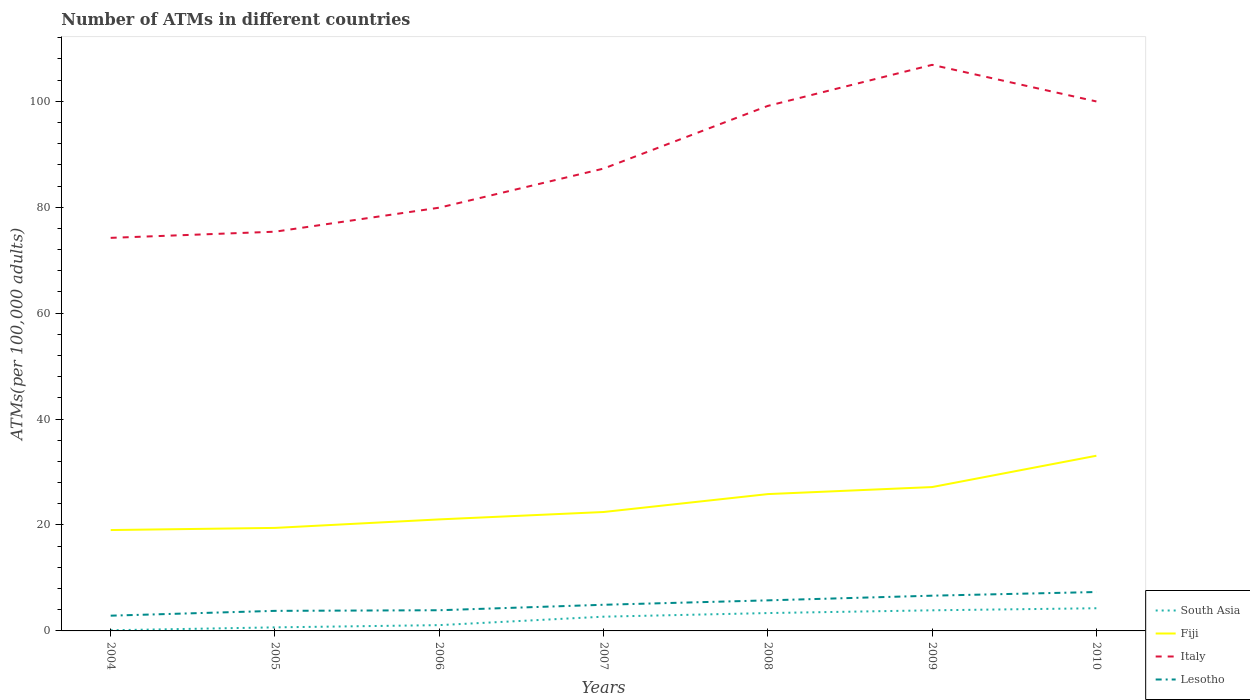How many different coloured lines are there?
Your answer should be very brief. 4. Is the number of lines equal to the number of legend labels?
Keep it short and to the point. Yes. Across all years, what is the maximum number of ATMs in Fiji?
Provide a succinct answer. 19.05. What is the total number of ATMs in Italy in the graph?
Your answer should be very brief. -4.53. What is the difference between the highest and the second highest number of ATMs in Italy?
Keep it short and to the point. 32.67. What is the difference between the highest and the lowest number of ATMs in Fiji?
Make the answer very short. 3. Is the number of ATMs in Lesotho strictly greater than the number of ATMs in Italy over the years?
Your response must be concise. Yes. What is the difference between two consecutive major ticks on the Y-axis?
Give a very brief answer. 20. Are the values on the major ticks of Y-axis written in scientific E-notation?
Provide a succinct answer. No. Where does the legend appear in the graph?
Offer a very short reply. Bottom right. What is the title of the graph?
Keep it short and to the point. Number of ATMs in different countries. Does "Europe(developing only)" appear as one of the legend labels in the graph?
Provide a succinct answer. No. What is the label or title of the Y-axis?
Make the answer very short. ATMs(per 100,0 adults). What is the ATMs(per 100,000 adults) in South Asia in 2004?
Offer a terse response. 0.12. What is the ATMs(per 100,000 adults) in Fiji in 2004?
Ensure brevity in your answer.  19.05. What is the ATMs(per 100,000 adults) in Italy in 2004?
Offer a terse response. 74.21. What is the ATMs(per 100,000 adults) in Lesotho in 2004?
Offer a very short reply. 2.88. What is the ATMs(per 100,000 adults) in South Asia in 2005?
Give a very brief answer. 0.67. What is the ATMs(per 100,000 adults) of Fiji in 2005?
Ensure brevity in your answer.  19.45. What is the ATMs(per 100,000 adults) of Italy in 2005?
Make the answer very short. 75.38. What is the ATMs(per 100,000 adults) of Lesotho in 2005?
Offer a very short reply. 3.79. What is the ATMs(per 100,000 adults) of South Asia in 2006?
Your answer should be compact. 1.09. What is the ATMs(per 100,000 adults) of Fiji in 2006?
Ensure brevity in your answer.  21.06. What is the ATMs(per 100,000 adults) of Italy in 2006?
Make the answer very short. 79.91. What is the ATMs(per 100,000 adults) in Lesotho in 2006?
Your answer should be compact. 3.91. What is the ATMs(per 100,000 adults) of South Asia in 2007?
Provide a short and direct response. 2.69. What is the ATMs(per 100,000 adults) in Fiji in 2007?
Provide a short and direct response. 22.45. What is the ATMs(per 100,000 adults) of Italy in 2007?
Ensure brevity in your answer.  87.29. What is the ATMs(per 100,000 adults) in Lesotho in 2007?
Provide a succinct answer. 4.94. What is the ATMs(per 100,000 adults) in South Asia in 2008?
Provide a succinct answer. 3.37. What is the ATMs(per 100,000 adults) of Fiji in 2008?
Keep it short and to the point. 25.83. What is the ATMs(per 100,000 adults) of Italy in 2008?
Your answer should be very brief. 99.13. What is the ATMs(per 100,000 adults) of Lesotho in 2008?
Offer a terse response. 5.77. What is the ATMs(per 100,000 adults) in South Asia in 2009?
Your answer should be compact. 3.89. What is the ATMs(per 100,000 adults) in Fiji in 2009?
Offer a terse response. 27.16. What is the ATMs(per 100,000 adults) in Italy in 2009?
Make the answer very short. 106.88. What is the ATMs(per 100,000 adults) in Lesotho in 2009?
Provide a short and direct response. 6.65. What is the ATMs(per 100,000 adults) in South Asia in 2010?
Ensure brevity in your answer.  4.28. What is the ATMs(per 100,000 adults) in Fiji in 2010?
Your answer should be very brief. 33.08. What is the ATMs(per 100,000 adults) of Italy in 2010?
Make the answer very short. 99.97. What is the ATMs(per 100,000 adults) of Lesotho in 2010?
Keep it short and to the point. 7.34. Across all years, what is the maximum ATMs(per 100,000 adults) in South Asia?
Your response must be concise. 4.28. Across all years, what is the maximum ATMs(per 100,000 adults) of Fiji?
Your response must be concise. 33.08. Across all years, what is the maximum ATMs(per 100,000 adults) in Italy?
Your answer should be very brief. 106.88. Across all years, what is the maximum ATMs(per 100,000 adults) in Lesotho?
Give a very brief answer. 7.34. Across all years, what is the minimum ATMs(per 100,000 adults) in South Asia?
Keep it short and to the point. 0.12. Across all years, what is the minimum ATMs(per 100,000 adults) in Fiji?
Keep it short and to the point. 19.05. Across all years, what is the minimum ATMs(per 100,000 adults) of Italy?
Provide a short and direct response. 74.21. Across all years, what is the minimum ATMs(per 100,000 adults) in Lesotho?
Give a very brief answer. 2.88. What is the total ATMs(per 100,000 adults) of South Asia in the graph?
Provide a succinct answer. 16.13. What is the total ATMs(per 100,000 adults) in Fiji in the graph?
Offer a very short reply. 168.08. What is the total ATMs(per 100,000 adults) in Italy in the graph?
Ensure brevity in your answer.  622.77. What is the total ATMs(per 100,000 adults) in Lesotho in the graph?
Keep it short and to the point. 35.28. What is the difference between the ATMs(per 100,000 adults) of South Asia in 2004 and that in 2005?
Your answer should be compact. -0.55. What is the difference between the ATMs(per 100,000 adults) of Fiji in 2004 and that in 2005?
Provide a short and direct response. -0.4. What is the difference between the ATMs(per 100,000 adults) in Italy in 2004 and that in 2005?
Offer a very short reply. -1.16. What is the difference between the ATMs(per 100,000 adults) in Lesotho in 2004 and that in 2005?
Your response must be concise. -0.91. What is the difference between the ATMs(per 100,000 adults) in South Asia in 2004 and that in 2006?
Your response must be concise. -0.97. What is the difference between the ATMs(per 100,000 adults) of Fiji in 2004 and that in 2006?
Make the answer very short. -2.01. What is the difference between the ATMs(per 100,000 adults) of Italy in 2004 and that in 2006?
Offer a very short reply. -5.7. What is the difference between the ATMs(per 100,000 adults) in Lesotho in 2004 and that in 2006?
Provide a succinct answer. -1.03. What is the difference between the ATMs(per 100,000 adults) in South Asia in 2004 and that in 2007?
Make the answer very short. -2.56. What is the difference between the ATMs(per 100,000 adults) in Fiji in 2004 and that in 2007?
Offer a very short reply. -3.4. What is the difference between the ATMs(per 100,000 adults) in Italy in 2004 and that in 2007?
Make the answer very short. -13.08. What is the difference between the ATMs(per 100,000 adults) of Lesotho in 2004 and that in 2007?
Your answer should be compact. -2.06. What is the difference between the ATMs(per 100,000 adults) of South Asia in 2004 and that in 2008?
Your response must be concise. -3.25. What is the difference between the ATMs(per 100,000 adults) in Fiji in 2004 and that in 2008?
Ensure brevity in your answer.  -6.79. What is the difference between the ATMs(per 100,000 adults) in Italy in 2004 and that in 2008?
Provide a succinct answer. -24.91. What is the difference between the ATMs(per 100,000 adults) in Lesotho in 2004 and that in 2008?
Keep it short and to the point. -2.89. What is the difference between the ATMs(per 100,000 adults) in South Asia in 2004 and that in 2009?
Your answer should be compact. -3.77. What is the difference between the ATMs(per 100,000 adults) in Fiji in 2004 and that in 2009?
Give a very brief answer. -8.12. What is the difference between the ATMs(per 100,000 adults) in Italy in 2004 and that in 2009?
Your answer should be compact. -32.67. What is the difference between the ATMs(per 100,000 adults) of Lesotho in 2004 and that in 2009?
Make the answer very short. -3.78. What is the difference between the ATMs(per 100,000 adults) of South Asia in 2004 and that in 2010?
Your answer should be compact. -4.16. What is the difference between the ATMs(per 100,000 adults) in Fiji in 2004 and that in 2010?
Ensure brevity in your answer.  -14.03. What is the difference between the ATMs(per 100,000 adults) in Italy in 2004 and that in 2010?
Ensure brevity in your answer.  -25.75. What is the difference between the ATMs(per 100,000 adults) in Lesotho in 2004 and that in 2010?
Offer a terse response. -4.46. What is the difference between the ATMs(per 100,000 adults) of South Asia in 2005 and that in 2006?
Your response must be concise. -0.42. What is the difference between the ATMs(per 100,000 adults) in Fiji in 2005 and that in 2006?
Your answer should be very brief. -1.61. What is the difference between the ATMs(per 100,000 adults) in Italy in 2005 and that in 2006?
Keep it short and to the point. -4.53. What is the difference between the ATMs(per 100,000 adults) of Lesotho in 2005 and that in 2006?
Keep it short and to the point. -0.12. What is the difference between the ATMs(per 100,000 adults) in South Asia in 2005 and that in 2007?
Offer a very short reply. -2.02. What is the difference between the ATMs(per 100,000 adults) in Fiji in 2005 and that in 2007?
Provide a short and direct response. -3. What is the difference between the ATMs(per 100,000 adults) of Italy in 2005 and that in 2007?
Offer a very short reply. -11.91. What is the difference between the ATMs(per 100,000 adults) in Lesotho in 2005 and that in 2007?
Your response must be concise. -1.15. What is the difference between the ATMs(per 100,000 adults) in South Asia in 2005 and that in 2008?
Ensure brevity in your answer.  -2.7. What is the difference between the ATMs(per 100,000 adults) in Fiji in 2005 and that in 2008?
Make the answer very short. -6.38. What is the difference between the ATMs(per 100,000 adults) of Italy in 2005 and that in 2008?
Your response must be concise. -23.75. What is the difference between the ATMs(per 100,000 adults) of Lesotho in 2005 and that in 2008?
Make the answer very short. -1.98. What is the difference between the ATMs(per 100,000 adults) of South Asia in 2005 and that in 2009?
Offer a terse response. -3.22. What is the difference between the ATMs(per 100,000 adults) in Fiji in 2005 and that in 2009?
Your answer should be very brief. -7.71. What is the difference between the ATMs(per 100,000 adults) in Italy in 2005 and that in 2009?
Provide a short and direct response. -31.5. What is the difference between the ATMs(per 100,000 adults) in Lesotho in 2005 and that in 2009?
Make the answer very short. -2.87. What is the difference between the ATMs(per 100,000 adults) in South Asia in 2005 and that in 2010?
Your answer should be compact. -3.61. What is the difference between the ATMs(per 100,000 adults) in Fiji in 2005 and that in 2010?
Ensure brevity in your answer.  -13.63. What is the difference between the ATMs(per 100,000 adults) of Italy in 2005 and that in 2010?
Provide a short and direct response. -24.59. What is the difference between the ATMs(per 100,000 adults) of Lesotho in 2005 and that in 2010?
Ensure brevity in your answer.  -3.56. What is the difference between the ATMs(per 100,000 adults) of South Asia in 2006 and that in 2007?
Ensure brevity in your answer.  -1.6. What is the difference between the ATMs(per 100,000 adults) in Fiji in 2006 and that in 2007?
Ensure brevity in your answer.  -1.39. What is the difference between the ATMs(per 100,000 adults) in Italy in 2006 and that in 2007?
Give a very brief answer. -7.38. What is the difference between the ATMs(per 100,000 adults) of Lesotho in 2006 and that in 2007?
Your response must be concise. -1.03. What is the difference between the ATMs(per 100,000 adults) in South Asia in 2006 and that in 2008?
Give a very brief answer. -2.28. What is the difference between the ATMs(per 100,000 adults) in Fiji in 2006 and that in 2008?
Ensure brevity in your answer.  -4.78. What is the difference between the ATMs(per 100,000 adults) in Italy in 2006 and that in 2008?
Give a very brief answer. -19.22. What is the difference between the ATMs(per 100,000 adults) of Lesotho in 2006 and that in 2008?
Offer a very short reply. -1.87. What is the difference between the ATMs(per 100,000 adults) in South Asia in 2006 and that in 2009?
Keep it short and to the point. -2.8. What is the difference between the ATMs(per 100,000 adults) in Fiji in 2006 and that in 2009?
Offer a very short reply. -6.1. What is the difference between the ATMs(per 100,000 adults) of Italy in 2006 and that in 2009?
Make the answer very short. -26.97. What is the difference between the ATMs(per 100,000 adults) in Lesotho in 2006 and that in 2009?
Give a very brief answer. -2.75. What is the difference between the ATMs(per 100,000 adults) in South Asia in 2006 and that in 2010?
Your answer should be compact. -3.19. What is the difference between the ATMs(per 100,000 adults) in Fiji in 2006 and that in 2010?
Your answer should be very brief. -12.02. What is the difference between the ATMs(per 100,000 adults) of Italy in 2006 and that in 2010?
Keep it short and to the point. -20.06. What is the difference between the ATMs(per 100,000 adults) of Lesotho in 2006 and that in 2010?
Ensure brevity in your answer.  -3.44. What is the difference between the ATMs(per 100,000 adults) of South Asia in 2007 and that in 2008?
Provide a succinct answer. -0.68. What is the difference between the ATMs(per 100,000 adults) in Fiji in 2007 and that in 2008?
Offer a very short reply. -3.38. What is the difference between the ATMs(per 100,000 adults) in Italy in 2007 and that in 2008?
Offer a very short reply. -11.84. What is the difference between the ATMs(per 100,000 adults) in Lesotho in 2007 and that in 2008?
Your answer should be very brief. -0.83. What is the difference between the ATMs(per 100,000 adults) in South Asia in 2007 and that in 2009?
Make the answer very short. -1.2. What is the difference between the ATMs(per 100,000 adults) in Fiji in 2007 and that in 2009?
Provide a short and direct response. -4.71. What is the difference between the ATMs(per 100,000 adults) in Italy in 2007 and that in 2009?
Offer a very short reply. -19.59. What is the difference between the ATMs(per 100,000 adults) in Lesotho in 2007 and that in 2009?
Offer a very short reply. -1.72. What is the difference between the ATMs(per 100,000 adults) of South Asia in 2007 and that in 2010?
Your answer should be compact. -1.59. What is the difference between the ATMs(per 100,000 adults) of Fiji in 2007 and that in 2010?
Keep it short and to the point. -10.63. What is the difference between the ATMs(per 100,000 adults) of Italy in 2007 and that in 2010?
Provide a succinct answer. -12.68. What is the difference between the ATMs(per 100,000 adults) of Lesotho in 2007 and that in 2010?
Offer a terse response. -2.41. What is the difference between the ATMs(per 100,000 adults) in South Asia in 2008 and that in 2009?
Ensure brevity in your answer.  -0.52. What is the difference between the ATMs(per 100,000 adults) in Fiji in 2008 and that in 2009?
Give a very brief answer. -1.33. What is the difference between the ATMs(per 100,000 adults) in Italy in 2008 and that in 2009?
Your answer should be very brief. -7.75. What is the difference between the ATMs(per 100,000 adults) in Lesotho in 2008 and that in 2009?
Ensure brevity in your answer.  -0.88. What is the difference between the ATMs(per 100,000 adults) in South Asia in 2008 and that in 2010?
Your response must be concise. -0.91. What is the difference between the ATMs(per 100,000 adults) of Fiji in 2008 and that in 2010?
Keep it short and to the point. -7.24. What is the difference between the ATMs(per 100,000 adults) of Italy in 2008 and that in 2010?
Offer a terse response. -0.84. What is the difference between the ATMs(per 100,000 adults) in Lesotho in 2008 and that in 2010?
Your response must be concise. -1.57. What is the difference between the ATMs(per 100,000 adults) in South Asia in 2009 and that in 2010?
Your answer should be very brief. -0.39. What is the difference between the ATMs(per 100,000 adults) of Fiji in 2009 and that in 2010?
Give a very brief answer. -5.92. What is the difference between the ATMs(per 100,000 adults) in Italy in 2009 and that in 2010?
Make the answer very short. 6.91. What is the difference between the ATMs(per 100,000 adults) in Lesotho in 2009 and that in 2010?
Give a very brief answer. -0.69. What is the difference between the ATMs(per 100,000 adults) of South Asia in 2004 and the ATMs(per 100,000 adults) of Fiji in 2005?
Ensure brevity in your answer.  -19.33. What is the difference between the ATMs(per 100,000 adults) of South Asia in 2004 and the ATMs(per 100,000 adults) of Italy in 2005?
Keep it short and to the point. -75.25. What is the difference between the ATMs(per 100,000 adults) of South Asia in 2004 and the ATMs(per 100,000 adults) of Lesotho in 2005?
Your answer should be very brief. -3.66. What is the difference between the ATMs(per 100,000 adults) of Fiji in 2004 and the ATMs(per 100,000 adults) of Italy in 2005?
Provide a succinct answer. -56.33. What is the difference between the ATMs(per 100,000 adults) in Fiji in 2004 and the ATMs(per 100,000 adults) in Lesotho in 2005?
Offer a terse response. 15.26. What is the difference between the ATMs(per 100,000 adults) of Italy in 2004 and the ATMs(per 100,000 adults) of Lesotho in 2005?
Give a very brief answer. 70.43. What is the difference between the ATMs(per 100,000 adults) in South Asia in 2004 and the ATMs(per 100,000 adults) in Fiji in 2006?
Give a very brief answer. -20.93. What is the difference between the ATMs(per 100,000 adults) of South Asia in 2004 and the ATMs(per 100,000 adults) of Italy in 2006?
Provide a succinct answer. -79.79. What is the difference between the ATMs(per 100,000 adults) of South Asia in 2004 and the ATMs(per 100,000 adults) of Lesotho in 2006?
Your response must be concise. -3.78. What is the difference between the ATMs(per 100,000 adults) in Fiji in 2004 and the ATMs(per 100,000 adults) in Italy in 2006?
Ensure brevity in your answer.  -60.87. What is the difference between the ATMs(per 100,000 adults) of Fiji in 2004 and the ATMs(per 100,000 adults) of Lesotho in 2006?
Your answer should be very brief. 15.14. What is the difference between the ATMs(per 100,000 adults) in Italy in 2004 and the ATMs(per 100,000 adults) in Lesotho in 2006?
Offer a terse response. 70.31. What is the difference between the ATMs(per 100,000 adults) of South Asia in 2004 and the ATMs(per 100,000 adults) of Fiji in 2007?
Your response must be concise. -22.33. What is the difference between the ATMs(per 100,000 adults) of South Asia in 2004 and the ATMs(per 100,000 adults) of Italy in 2007?
Offer a very short reply. -87.17. What is the difference between the ATMs(per 100,000 adults) in South Asia in 2004 and the ATMs(per 100,000 adults) in Lesotho in 2007?
Make the answer very short. -4.81. What is the difference between the ATMs(per 100,000 adults) of Fiji in 2004 and the ATMs(per 100,000 adults) of Italy in 2007?
Your answer should be very brief. -68.24. What is the difference between the ATMs(per 100,000 adults) in Fiji in 2004 and the ATMs(per 100,000 adults) in Lesotho in 2007?
Offer a very short reply. 14.11. What is the difference between the ATMs(per 100,000 adults) in Italy in 2004 and the ATMs(per 100,000 adults) in Lesotho in 2007?
Ensure brevity in your answer.  69.28. What is the difference between the ATMs(per 100,000 adults) of South Asia in 2004 and the ATMs(per 100,000 adults) of Fiji in 2008?
Ensure brevity in your answer.  -25.71. What is the difference between the ATMs(per 100,000 adults) of South Asia in 2004 and the ATMs(per 100,000 adults) of Italy in 2008?
Make the answer very short. -99. What is the difference between the ATMs(per 100,000 adults) of South Asia in 2004 and the ATMs(per 100,000 adults) of Lesotho in 2008?
Your response must be concise. -5.65. What is the difference between the ATMs(per 100,000 adults) of Fiji in 2004 and the ATMs(per 100,000 adults) of Italy in 2008?
Ensure brevity in your answer.  -80.08. What is the difference between the ATMs(per 100,000 adults) in Fiji in 2004 and the ATMs(per 100,000 adults) in Lesotho in 2008?
Make the answer very short. 13.28. What is the difference between the ATMs(per 100,000 adults) in Italy in 2004 and the ATMs(per 100,000 adults) in Lesotho in 2008?
Keep it short and to the point. 68.44. What is the difference between the ATMs(per 100,000 adults) of South Asia in 2004 and the ATMs(per 100,000 adults) of Fiji in 2009?
Your answer should be very brief. -27.04. What is the difference between the ATMs(per 100,000 adults) of South Asia in 2004 and the ATMs(per 100,000 adults) of Italy in 2009?
Offer a very short reply. -106.76. What is the difference between the ATMs(per 100,000 adults) in South Asia in 2004 and the ATMs(per 100,000 adults) in Lesotho in 2009?
Your response must be concise. -6.53. What is the difference between the ATMs(per 100,000 adults) in Fiji in 2004 and the ATMs(per 100,000 adults) in Italy in 2009?
Give a very brief answer. -87.83. What is the difference between the ATMs(per 100,000 adults) in Fiji in 2004 and the ATMs(per 100,000 adults) in Lesotho in 2009?
Offer a terse response. 12.39. What is the difference between the ATMs(per 100,000 adults) of Italy in 2004 and the ATMs(per 100,000 adults) of Lesotho in 2009?
Offer a terse response. 67.56. What is the difference between the ATMs(per 100,000 adults) of South Asia in 2004 and the ATMs(per 100,000 adults) of Fiji in 2010?
Ensure brevity in your answer.  -32.95. What is the difference between the ATMs(per 100,000 adults) of South Asia in 2004 and the ATMs(per 100,000 adults) of Italy in 2010?
Provide a succinct answer. -99.84. What is the difference between the ATMs(per 100,000 adults) in South Asia in 2004 and the ATMs(per 100,000 adults) in Lesotho in 2010?
Your response must be concise. -7.22. What is the difference between the ATMs(per 100,000 adults) in Fiji in 2004 and the ATMs(per 100,000 adults) in Italy in 2010?
Give a very brief answer. -80.92. What is the difference between the ATMs(per 100,000 adults) of Fiji in 2004 and the ATMs(per 100,000 adults) of Lesotho in 2010?
Provide a succinct answer. 11.7. What is the difference between the ATMs(per 100,000 adults) in Italy in 2004 and the ATMs(per 100,000 adults) in Lesotho in 2010?
Offer a very short reply. 66.87. What is the difference between the ATMs(per 100,000 adults) in South Asia in 2005 and the ATMs(per 100,000 adults) in Fiji in 2006?
Offer a terse response. -20.39. What is the difference between the ATMs(per 100,000 adults) of South Asia in 2005 and the ATMs(per 100,000 adults) of Italy in 2006?
Offer a terse response. -79.24. What is the difference between the ATMs(per 100,000 adults) of South Asia in 2005 and the ATMs(per 100,000 adults) of Lesotho in 2006?
Offer a very short reply. -3.23. What is the difference between the ATMs(per 100,000 adults) in Fiji in 2005 and the ATMs(per 100,000 adults) in Italy in 2006?
Make the answer very short. -60.46. What is the difference between the ATMs(per 100,000 adults) of Fiji in 2005 and the ATMs(per 100,000 adults) of Lesotho in 2006?
Ensure brevity in your answer.  15.55. What is the difference between the ATMs(per 100,000 adults) of Italy in 2005 and the ATMs(per 100,000 adults) of Lesotho in 2006?
Ensure brevity in your answer.  71.47. What is the difference between the ATMs(per 100,000 adults) in South Asia in 2005 and the ATMs(per 100,000 adults) in Fiji in 2007?
Provide a succinct answer. -21.78. What is the difference between the ATMs(per 100,000 adults) of South Asia in 2005 and the ATMs(per 100,000 adults) of Italy in 2007?
Your answer should be compact. -86.62. What is the difference between the ATMs(per 100,000 adults) of South Asia in 2005 and the ATMs(per 100,000 adults) of Lesotho in 2007?
Your response must be concise. -4.27. What is the difference between the ATMs(per 100,000 adults) of Fiji in 2005 and the ATMs(per 100,000 adults) of Italy in 2007?
Keep it short and to the point. -67.84. What is the difference between the ATMs(per 100,000 adults) in Fiji in 2005 and the ATMs(per 100,000 adults) in Lesotho in 2007?
Keep it short and to the point. 14.51. What is the difference between the ATMs(per 100,000 adults) of Italy in 2005 and the ATMs(per 100,000 adults) of Lesotho in 2007?
Provide a short and direct response. 70.44. What is the difference between the ATMs(per 100,000 adults) of South Asia in 2005 and the ATMs(per 100,000 adults) of Fiji in 2008?
Offer a very short reply. -25.16. What is the difference between the ATMs(per 100,000 adults) in South Asia in 2005 and the ATMs(per 100,000 adults) in Italy in 2008?
Offer a terse response. -98.46. What is the difference between the ATMs(per 100,000 adults) in South Asia in 2005 and the ATMs(per 100,000 adults) in Lesotho in 2008?
Offer a very short reply. -5.1. What is the difference between the ATMs(per 100,000 adults) in Fiji in 2005 and the ATMs(per 100,000 adults) in Italy in 2008?
Give a very brief answer. -79.68. What is the difference between the ATMs(per 100,000 adults) of Fiji in 2005 and the ATMs(per 100,000 adults) of Lesotho in 2008?
Provide a succinct answer. 13.68. What is the difference between the ATMs(per 100,000 adults) of Italy in 2005 and the ATMs(per 100,000 adults) of Lesotho in 2008?
Make the answer very short. 69.61. What is the difference between the ATMs(per 100,000 adults) of South Asia in 2005 and the ATMs(per 100,000 adults) of Fiji in 2009?
Provide a succinct answer. -26.49. What is the difference between the ATMs(per 100,000 adults) in South Asia in 2005 and the ATMs(per 100,000 adults) in Italy in 2009?
Your answer should be compact. -106.21. What is the difference between the ATMs(per 100,000 adults) of South Asia in 2005 and the ATMs(per 100,000 adults) of Lesotho in 2009?
Provide a succinct answer. -5.98. What is the difference between the ATMs(per 100,000 adults) of Fiji in 2005 and the ATMs(per 100,000 adults) of Italy in 2009?
Your answer should be compact. -87.43. What is the difference between the ATMs(per 100,000 adults) of Fiji in 2005 and the ATMs(per 100,000 adults) of Lesotho in 2009?
Ensure brevity in your answer.  12.8. What is the difference between the ATMs(per 100,000 adults) of Italy in 2005 and the ATMs(per 100,000 adults) of Lesotho in 2009?
Offer a terse response. 68.72. What is the difference between the ATMs(per 100,000 adults) in South Asia in 2005 and the ATMs(per 100,000 adults) in Fiji in 2010?
Ensure brevity in your answer.  -32.41. What is the difference between the ATMs(per 100,000 adults) of South Asia in 2005 and the ATMs(per 100,000 adults) of Italy in 2010?
Your response must be concise. -99.3. What is the difference between the ATMs(per 100,000 adults) of South Asia in 2005 and the ATMs(per 100,000 adults) of Lesotho in 2010?
Provide a short and direct response. -6.67. What is the difference between the ATMs(per 100,000 adults) of Fiji in 2005 and the ATMs(per 100,000 adults) of Italy in 2010?
Provide a succinct answer. -80.52. What is the difference between the ATMs(per 100,000 adults) in Fiji in 2005 and the ATMs(per 100,000 adults) in Lesotho in 2010?
Offer a very short reply. 12.11. What is the difference between the ATMs(per 100,000 adults) in Italy in 2005 and the ATMs(per 100,000 adults) in Lesotho in 2010?
Provide a succinct answer. 68.03. What is the difference between the ATMs(per 100,000 adults) of South Asia in 2006 and the ATMs(per 100,000 adults) of Fiji in 2007?
Ensure brevity in your answer.  -21.36. What is the difference between the ATMs(per 100,000 adults) of South Asia in 2006 and the ATMs(per 100,000 adults) of Italy in 2007?
Keep it short and to the point. -86.2. What is the difference between the ATMs(per 100,000 adults) in South Asia in 2006 and the ATMs(per 100,000 adults) in Lesotho in 2007?
Your response must be concise. -3.84. What is the difference between the ATMs(per 100,000 adults) of Fiji in 2006 and the ATMs(per 100,000 adults) of Italy in 2007?
Offer a very short reply. -66.23. What is the difference between the ATMs(per 100,000 adults) of Fiji in 2006 and the ATMs(per 100,000 adults) of Lesotho in 2007?
Make the answer very short. 16.12. What is the difference between the ATMs(per 100,000 adults) in Italy in 2006 and the ATMs(per 100,000 adults) in Lesotho in 2007?
Keep it short and to the point. 74.97. What is the difference between the ATMs(per 100,000 adults) in South Asia in 2006 and the ATMs(per 100,000 adults) in Fiji in 2008?
Your answer should be compact. -24.74. What is the difference between the ATMs(per 100,000 adults) of South Asia in 2006 and the ATMs(per 100,000 adults) of Italy in 2008?
Your response must be concise. -98.03. What is the difference between the ATMs(per 100,000 adults) of South Asia in 2006 and the ATMs(per 100,000 adults) of Lesotho in 2008?
Offer a terse response. -4.68. What is the difference between the ATMs(per 100,000 adults) of Fiji in 2006 and the ATMs(per 100,000 adults) of Italy in 2008?
Your answer should be compact. -78.07. What is the difference between the ATMs(per 100,000 adults) of Fiji in 2006 and the ATMs(per 100,000 adults) of Lesotho in 2008?
Ensure brevity in your answer.  15.29. What is the difference between the ATMs(per 100,000 adults) of Italy in 2006 and the ATMs(per 100,000 adults) of Lesotho in 2008?
Your response must be concise. 74.14. What is the difference between the ATMs(per 100,000 adults) in South Asia in 2006 and the ATMs(per 100,000 adults) in Fiji in 2009?
Your answer should be very brief. -26.07. What is the difference between the ATMs(per 100,000 adults) of South Asia in 2006 and the ATMs(per 100,000 adults) of Italy in 2009?
Give a very brief answer. -105.79. What is the difference between the ATMs(per 100,000 adults) in South Asia in 2006 and the ATMs(per 100,000 adults) in Lesotho in 2009?
Your response must be concise. -5.56. What is the difference between the ATMs(per 100,000 adults) of Fiji in 2006 and the ATMs(per 100,000 adults) of Italy in 2009?
Provide a short and direct response. -85.82. What is the difference between the ATMs(per 100,000 adults) in Fiji in 2006 and the ATMs(per 100,000 adults) in Lesotho in 2009?
Keep it short and to the point. 14.4. What is the difference between the ATMs(per 100,000 adults) in Italy in 2006 and the ATMs(per 100,000 adults) in Lesotho in 2009?
Make the answer very short. 73.26. What is the difference between the ATMs(per 100,000 adults) in South Asia in 2006 and the ATMs(per 100,000 adults) in Fiji in 2010?
Make the answer very short. -31.98. What is the difference between the ATMs(per 100,000 adults) of South Asia in 2006 and the ATMs(per 100,000 adults) of Italy in 2010?
Offer a terse response. -98.87. What is the difference between the ATMs(per 100,000 adults) in South Asia in 2006 and the ATMs(per 100,000 adults) in Lesotho in 2010?
Offer a terse response. -6.25. What is the difference between the ATMs(per 100,000 adults) of Fiji in 2006 and the ATMs(per 100,000 adults) of Italy in 2010?
Offer a terse response. -78.91. What is the difference between the ATMs(per 100,000 adults) of Fiji in 2006 and the ATMs(per 100,000 adults) of Lesotho in 2010?
Provide a short and direct response. 13.71. What is the difference between the ATMs(per 100,000 adults) in Italy in 2006 and the ATMs(per 100,000 adults) in Lesotho in 2010?
Ensure brevity in your answer.  72.57. What is the difference between the ATMs(per 100,000 adults) of South Asia in 2007 and the ATMs(per 100,000 adults) of Fiji in 2008?
Ensure brevity in your answer.  -23.14. What is the difference between the ATMs(per 100,000 adults) in South Asia in 2007 and the ATMs(per 100,000 adults) in Italy in 2008?
Give a very brief answer. -96.44. What is the difference between the ATMs(per 100,000 adults) in South Asia in 2007 and the ATMs(per 100,000 adults) in Lesotho in 2008?
Offer a terse response. -3.08. What is the difference between the ATMs(per 100,000 adults) of Fiji in 2007 and the ATMs(per 100,000 adults) of Italy in 2008?
Make the answer very short. -76.68. What is the difference between the ATMs(per 100,000 adults) in Fiji in 2007 and the ATMs(per 100,000 adults) in Lesotho in 2008?
Give a very brief answer. 16.68. What is the difference between the ATMs(per 100,000 adults) of Italy in 2007 and the ATMs(per 100,000 adults) of Lesotho in 2008?
Provide a succinct answer. 81.52. What is the difference between the ATMs(per 100,000 adults) in South Asia in 2007 and the ATMs(per 100,000 adults) in Fiji in 2009?
Provide a short and direct response. -24.47. What is the difference between the ATMs(per 100,000 adults) of South Asia in 2007 and the ATMs(per 100,000 adults) of Italy in 2009?
Your response must be concise. -104.19. What is the difference between the ATMs(per 100,000 adults) in South Asia in 2007 and the ATMs(per 100,000 adults) in Lesotho in 2009?
Your answer should be compact. -3.96. What is the difference between the ATMs(per 100,000 adults) of Fiji in 2007 and the ATMs(per 100,000 adults) of Italy in 2009?
Give a very brief answer. -84.43. What is the difference between the ATMs(per 100,000 adults) in Fiji in 2007 and the ATMs(per 100,000 adults) in Lesotho in 2009?
Offer a terse response. 15.8. What is the difference between the ATMs(per 100,000 adults) in Italy in 2007 and the ATMs(per 100,000 adults) in Lesotho in 2009?
Provide a short and direct response. 80.64. What is the difference between the ATMs(per 100,000 adults) of South Asia in 2007 and the ATMs(per 100,000 adults) of Fiji in 2010?
Make the answer very short. -30.39. What is the difference between the ATMs(per 100,000 adults) in South Asia in 2007 and the ATMs(per 100,000 adults) in Italy in 2010?
Your answer should be compact. -97.28. What is the difference between the ATMs(per 100,000 adults) in South Asia in 2007 and the ATMs(per 100,000 adults) in Lesotho in 2010?
Your answer should be compact. -4.65. What is the difference between the ATMs(per 100,000 adults) in Fiji in 2007 and the ATMs(per 100,000 adults) in Italy in 2010?
Give a very brief answer. -77.52. What is the difference between the ATMs(per 100,000 adults) of Fiji in 2007 and the ATMs(per 100,000 adults) of Lesotho in 2010?
Provide a succinct answer. 15.11. What is the difference between the ATMs(per 100,000 adults) of Italy in 2007 and the ATMs(per 100,000 adults) of Lesotho in 2010?
Keep it short and to the point. 79.95. What is the difference between the ATMs(per 100,000 adults) in South Asia in 2008 and the ATMs(per 100,000 adults) in Fiji in 2009?
Offer a terse response. -23.79. What is the difference between the ATMs(per 100,000 adults) of South Asia in 2008 and the ATMs(per 100,000 adults) of Italy in 2009?
Provide a short and direct response. -103.51. What is the difference between the ATMs(per 100,000 adults) in South Asia in 2008 and the ATMs(per 100,000 adults) in Lesotho in 2009?
Offer a terse response. -3.28. What is the difference between the ATMs(per 100,000 adults) in Fiji in 2008 and the ATMs(per 100,000 adults) in Italy in 2009?
Your answer should be very brief. -81.05. What is the difference between the ATMs(per 100,000 adults) in Fiji in 2008 and the ATMs(per 100,000 adults) in Lesotho in 2009?
Provide a short and direct response. 19.18. What is the difference between the ATMs(per 100,000 adults) in Italy in 2008 and the ATMs(per 100,000 adults) in Lesotho in 2009?
Make the answer very short. 92.47. What is the difference between the ATMs(per 100,000 adults) in South Asia in 2008 and the ATMs(per 100,000 adults) in Fiji in 2010?
Your answer should be compact. -29.71. What is the difference between the ATMs(per 100,000 adults) in South Asia in 2008 and the ATMs(per 100,000 adults) in Italy in 2010?
Provide a succinct answer. -96.6. What is the difference between the ATMs(per 100,000 adults) in South Asia in 2008 and the ATMs(per 100,000 adults) in Lesotho in 2010?
Your answer should be compact. -3.97. What is the difference between the ATMs(per 100,000 adults) in Fiji in 2008 and the ATMs(per 100,000 adults) in Italy in 2010?
Keep it short and to the point. -74.14. What is the difference between the ATMs(per 100,000 adults) in Fiji in 2008 and the ATMs(per 100,000 adults) in Lesotho in 2010?
Offer a terse response. 18.49. What is the difference between the ATMs(per 100,000 adults) of Italy in 2008 and the ATMs(per 100,000 adults) of Lesotho in 2010?
Your response must be concise. 91.78. What is the difference between the ATMs(per 100,000 adults) in South Asia in 2009 and the ATMs(per 100,000 adults) in Fiji in 2010?
Offer a terse response. -29.19. What is the difference between the ATMs(per 100,000 adults) in South Asia in 2009 and the ATMs(per 100,000 adults) in Italy in 2010?
Ensure brevity in your answer.  -96.08. What is the difference between the ATMs(per 100,000 adults) of South Asia in 2009 and the ATMs(per 100,000 adults) of Lesotho in 2010?
Offer a terse response. -3.45. What is the difference between the ATMs(per 100,000 adults) of Fiji in 2009 and the ATMs(per 100,000 adults) of Italy in 2010?
Keep it short and to the point. -72.81. What is the difference between the ATMs(per 100,000 adults) in Fiji in 2009 and the ATMs(per 100,000 adults) in Lesotho in 2010?
Your response must be concise. 19.82. What is the difference between the ATMs(per 100,000 adults) of Italy in 2009 and the ATMs(per 100,000 adults) of Lesotho in 2010?
Your answer should be very brief. 99.54. What is the average ATMs(per 100,000 adults) in South Asia per year?
Keep it short and to the point. 2.3. What is the average ATMs(per 100,000 adults) of Fiji per year?
Ensure brevity in your answer.  24.01. What is the average ATMs(per 100,000 adults) in Italy per year?
Your answer should be compact. 88.97. What is the average ATMs(per 100,000 adults) in Lesotho per year?
Keep it short and to the point. 5.04. In the year 2004, what is the difference between the ATMs(per 100,000 adults) in South Asia and ATMs(per 100,000 adults) in Fiji?
Keep it short and to the point. -18.92. In the year 2004, what is the difference between the ATMs(per 100,000 adults) in South Asia and ATMs(per 100,000 adults) in Italy?
Make the answer very short. -74.09. In the year 2004, what is the difference between the ATMs(per 100,000 adults) in South Asia and ATMs(per 100,000 adults) in Lesotho?
Ensure brevity in your answer.  -2.75. In the year 2004, what is the difference between the ATMs(per 100,000 adults) of Fiji and ATMs(per 100,000 adults) of Italy?
Make the answer very short. -55.17. In the year 2004, what is the difference between the ATMs(per 100,000 adults) of Fiji and ATMs(per 100,000 adults) of Lesotho?
Provide a succinct answer. 16.17. In the year 2004, what is the difference between the ATMs(per 100,000 adults) of Italy and ATMs(per 100,000 adults) of Lesotho?
Your answer should be very brief. 71.34. In the year 2005, what is the difference between the ATMs(per 100,000 adults) of South Asia and ATMs(per 100,000 adults) of Fiji?
Your response must be concise. -18.78. In the year 2005, what is the difference between the ATMs(per 100,000 adults) of South Asia and ATMs(per 100,000 adults) of Italy?
Keep it short and to the point. -74.71. In the year 2005, what is the difference between the ATMs(per 100,000 adults) of South Asia and ATMs(per 100,000 adults) of Lesotho?
Give a very brief answer. -3.12. In the year 2005, what is the difference between the ATMs(per 100,000 adults) in Fiji and ATMs(per 100,000 adults) in Italy?
Give a very brief answer. -55.93. In the year 2005, what is the difference between the ATMs(per 100,000 adults) in Fiji and ATMs(per 100,000 adults) in Lesotho?
Offer a very short reply. 15.66. In the year 2005, what is the difference between the ATMs(per 100,000 adults) of Italy and ATMs(per 100,000 adults) of Lesotho?
Ensure brevity in your answer.  71.59. In the year 2006, what is the difference between the ATMs(per 100,000 adults) in South Asia and ATMs(per 100,000 adults) in Fiji?
Your response must be concise. -19.96. In the year 2006, what is the difference between the ATMs(per 100,000 adults) in South Asia and ATMs(per 100,000 adults) in Italy?
Offer a very short reply. -78.82. In the year 2006, what is the difference between the ATMs(per 100,000 adults) in South Asia and ATMs(per 100,000 adults) in Lesotho?
Offer a very short reply. -2.81. In the year 2006, what is the difference between the ATMs(per 100,000 adults) of Fiji and ATMs(per 100,000 adults) of Italy?
Make the answer very short. -58.85. In the year 2006, what is the difference between the ATMs(per 100,000 adults) in Fiji and ATMs(per 100,000 adults) in Lesotho?
Make the answer very short. 17.15. In the year 2006, what is the difference between the ATMs(per 100,000 adults) in Italy and ATMs(per 100,000 adults) in Lesotho?
Make the answer very short. 76.01. In the year 2007, what is the difference between the ATMs(per 100,000 adults) in South Asia and ATMs(per 100,000 adults) in Fiji?
Offer a very short reply. -19.76. In the year 2007, what is the difference between the ATMs(per 100,000 adults) in South Asia and ATMs(per 100,000 adults) in Italy?
Provide a short and direct response. -84.6. In the year 2007, what is the difference between the ATMs(per 100,000 adults) of South Asia and ATMs(per 100,000 adults) of Lesotho?
Your response must be concise. -2.25. In the year 2007, what is the difference between the ATMs(per 100,000 adults) in Fiji and ATMs(per 100,000 adults) in Italy?
Provide a succinct answer. -64.84. In the year 2007, what is the difference between the ATMs(per 100,000 adults) in Fiji and ATMs(per 100,000 adults) in Lesotho?
Provide a succinct answer. 17.51. In the year 2007, what is the difference between the ATMs(per 100,000 adults) in Italy and ATMs(per 100,000 adults) in Lesotho?
Keep it short and to the point. 82.35. In the year 2008, what is the difference between the ATMs(per 100,000 adults) in South Asia and ATMs(per 100,000 adults) in Fiji?
Offer a terse response. -22.46. In the year 2008, what is the difference between the ATMs(per 100,000 adults) in South Asia and ATMs(per 100,000 adults) in Italy?
Offer a terse response. -95.76. In the year 2008, what is the difference between the ATMs(per 100,000 adults) in South Asia and ATMs(per 100,000 adults) in Lesotho?
Keep it short and to the point. -2.4. In the year 2008, what is the difference between the ATMs(per 100,000 adults) of Fiji and ATMs(per 100,000 adults) of Italy?
Keep it short and to the point. -73.3. In the year 2008, what is the difference between the ATMs(per 100,000 adults) in Fiji and ATMs(per 100,000 adults) in Lesotho?
Your response must be concise. 20.06. In the year 2008, what is the difference between the ATMs(per 100,000 adults) of Italy and ATMs(per 100,000 adults) of Lesotho?
Provide a short and direct response. 93.36. In the year 2009, what is the difference between the ATMs(per 100,000 adults) of South Asia and ATMs(per 100,000 adults) of Fiji?
Your answer should be compact. -23.27. In the year 2009, what is the difference between the ATMs(per 100,000 adults) of South Asia and ATMs(per 100,000 adults) of Italy?
Offer a very short reply. -102.99. In the year 2009, what is the difference between the ATMs(per 100,000 adults) of South Asia and ATMs(per 100,000 adults) of Lesotho?
Make the answer very short. -2.76. In the year 2009, what is the difference between the ATMs(per 100,000 adults) of Fiji and ATMs(per 100,000 adults) of Italy?
Make the answer very short. -79.72. In the year 2009, what is the difference between the ATMs(per 100,000 adults) in Fiji and ATMs(per 100,000 adults) in Lesotho?
Provide a short and direct response. 20.51. In the year 2009, what is the difference between the ATMs(per 100,000 adults) in Italy and ATMs(per 100,000 adults) in Lesotho?
Provide a short and direct response. 100.23. In the year 2010, what is the difference between the ATMs(per 100,000 adults) of South Asia and ATMs(per 100,000 adults) of Fiji?
Provide a short and direct response. -28.8. In the year 2010, what is the difference between the ATMs(per 100,000 adults) of South Asia and ATMs(per 100,000 adults) of Italy?
Give a very brief answer. -95.69. In the year 2010, what is the difference between the ATMs(per 100,000 adults) in South Asia and ATMs(per 100,000 adults) in Lesotho?
Your response must be concise. -3.06. In the year 2010, what is the difference between the ATMs(per 100,000 adults) in Fiji and ATMs(per 100,000 adults) in Italy?
Your response must be concise. -66.89. In the year 2010, what is the difference between the ATMs(per 100,000 adults) in Fiji and ATMs(per 100,000 adults) in Lesotho?
Give a very brief answer. 25.73. In the year 2010, what is the difference between the ATMs(per 100,000 adults) of Italy and ATMs(per 100,000 adults) of Lesotho?
Your answer should be compact. 92.63. What is the ratio of the ATMs(per 100,000 adults) in South Asia in 2004 to that in 2005?
Your answer should be very brief. 0.19. What is the ratio of the ATMs(per 100,000 adults) in Fiji in 2004 to that in 2005?
Give a very brief answer. 0.98. What is the ratio of the ATMs(per 100,000 adults) in Italy in 2004 to that in 2005?
Ensure brevity in your answer.  0.98. What is the ratio of the ATMs(per 100,000 adults) in Lesotho in 2004 to that in 2005?
Offer a terse response. 0.76. What is the ratio of the ATMs(per 100,000 adults) in South Asia in 2004 to that in 2006?
Offer a terse response. 0.11. What is the ratio of the ATMs(per 100,000 adults) in Fiji in 2004 to that in 2006?
Your response must be concise. 0.9. What is the ratio of the ATMs(per 100,000 adults) in Italy in 2004 to that in 2006?
Keep it short and to the point. 0.93. What is the ratio of the ATMs(per 100,000 adults) of Lesotho in 2004 to that in 2006?
Keep it short and to the point. 0.74. What is the ratio of the ATMs(per 100,000 adults) in South Asia in 2004 to that in 2007?
Give a very brief answer. 0.05. What is the ratio of the ATMs(per 100,000 adults) of Fiji in 2004 to that in 2007?
Your answer should be compact. 0.85. What is the ratio of the ATMs(per 100,000 adults) in Italy in 2004 to that in 2007?
Keep it short and to the point. 0.85. What is the ratio of the ATMs(per 100,000 adults) in Lesotho in 2004 to that in 2007?
Provide a succinct answer. 0.58. What is the ratio of the ATMs(per 100,000 adults) in South Asia in 2004 to that in 2008?
Offer a very short reply. 0.04. What is the ratio of the ATMs(per 100,000 adults) of Fiji in 2004 to that in 2008?
Provide a succinct answer. 0.74. What is the ratio of the ATMs(per 100,000 adults) of Italy in 2004 to that in 2008?
Your answer should be very brief. 0.75. What is the ratio of the ATMs(per 100,000 adults) of Lesotho in 2004 to that in 2008?
Your answer should be compact. 0.5. What is the ratio of the ATMs(per 100,000 adults) in South Asia in 2004 to that in 2009?
Your response must be concise. 0.03. What is the ratio of the ATMs(per 100,000 adults) of Fiji in 2004 to that in 2009?
Ensure brevity in your answer.  0.7. What is the ratio of the ATMs(per 100,000 adults) of Italy in 2004 to that in 2009?
Make the answer very short. 0.69. What is the ratio of the ATMs(per 100,000 adults) in Lesotho in 2004 to that in 2009?
Your answer should be compact. 0.43. What is the ratio of the ATMs(per 100,000 adults) of South Asia in 2004 to that in 2010?
Make the answer very short. 0.03. What is the ratio of the ATMs(per 100,000 adults) of Fiji in 2004 to that in 2010?
Offer a very short reply. 0.58. What is the ratio of the ATMs(per 100,000 adults) of Italy in 2004 to that in 2010?
Your response must be concise. 0.74. What is the ratio of the ATMs(per 100,000 adults) in Lesotho in 2004 to that in 2010?
Your answer should be compact. 0.39. What is the ratio of the ATMs(per 100,000 adults) in South Asia in 2005 to that in 2006?
Ensure brevity in your answer.  0.61. What is the ratio of the ATMs(per 100,000 adults) in Fiji in 2005 to that in 2006?
Offer a very short reply. 0.92. What is the ratio of the ATMs(per 100,000 adults) in Italy in 2005 to that in 2006?
Provide a short and direct response. 0.94. What is the ratio of the ATMs(per 100,000 adults) in Lesotho in 2005 to that in 2006?
Your response must be concise. 0.97. What is the ratio of the ATMs(per 100,000 adults) in South Asia in 2005 to that in 2007?
Your answer should be very brief. 0.25. What is the ratio of the ATMs(per 100,000 adults) in Fiji in 2005 to that in 2007?
Your answer should be compact. 0.87. What is the ratio of the ATMs(per 100,000 adults) of Italy in 2005 to that in 2007?
Your answer should be compact. 0.86. What is the ratio of the ATMs(per 100,000 adults) in Lesotho in 2005 to that in 2007?
Provide a succinct answer. 0.77. What is the ratio of the ATMs(per 100,000 adults) in South Asia in 2005 to that in 2008?
Ensure brevity in your answer.  0.2. What is the ratio of the ATMs(per 100,000 adults) in Fiji in 2005 to that in 2008?
Keep it short and to the point. 0.75. What is the ratio of the ATMs(per 100,000 adults) in Italy in 2005 to that in 2008?
Your answer should be very brief. 0.76. What is the ratio of the ATMs(per 100,000 adults) in Lesotho in 2005 to that in 2008?
Give a very brief answer. 0.66. What is the ratio of the ATMs(per 100,000 adults) of South Asia in 2005 to that in 2009?
Make the answer very short. 0.17. What is the ratio of the ATMs(per 100,000 adults) in Fiji in 2005 to that in 2009?
Make the answer very short. 0.72. What is the ratio of the ATMs(per 100,000 adults) in Italy in 2005 to that in 2009?
Your response must be concise. 0.71. What is the ratio of the ATMs(per 100,000 adults) in Lesotho in 2005 to that in 2009?
Ensure brevity in your answer.  0.57. What is the ratio of the ATMs(per 100,000 adults) in South Asia in 2005 to that in 2010?
Provide a short and direct response. 0.16. What is the ratio of the ATMs(per 100,000 adults) of Fiji in 2005 to that in 2010?
Your answer should be very brief. 0.59. What is the ratio of the ATMs(per 100,000 adults) in Italy in 2005 to that in 2010?
Make the answer very short. 0.75. What is the ratio of the ATMs(per 100,000 adults) in Lesotho in 2005 to that in 2010?
Offer a terse response. 0.52. What is the ratio of the ATMs(per 100,000 adults) in South Asia in 2006 to that in 2007?
Make the answer very short. 0.41. What is the ratio of the ATMs(per 100,000 adults) of Fiji in 2006 to that in 2007?
Offer a very short reply. 0.94. What is the ratio of the ATMs(per 100,000 adults) of Italy in 2006 to that in 2007?
Keep it short and to the point. 0.92. What is the ratio of the ATMs(per 100,000 adults) of Lesotho in 2006 to that in 2007?
Provide a short and direct response. 0.79. What is the ratio of the ATMs(per 100,000 adults) of South Asia in 2006 to that in 2008?
Ensure brevity in your answer.  0.32. What is the ratio of the ATMs(per 100,000 adults) of Fiji in 2006 to that in 2008?
Make the answer very short. 0.82. What is the ratio of the ATMs(per 100,000 adults) of Italy in 2006 to that in 2008?
Your response must be concise. 0.81. What is the ratio of the ATMs(per 100,000 adults) of Lesotho in 2006 to that in 2008?
Keep it short and to the point. 0.68. What is the ratio of the ATMs(per 100,000 adults) in South Asia in 2006 to that in 2009?
Offer a very short reply. 0.28. What is the ratio of the ATMs(per 100,000 adults) of Fiji in 2006 to that in 2009?
Give a very brief answer. 0.78. What is the ratio of the ATMs(per 100,000 adults) in Italy in 2006 to that in 2009?
Provide a succinct answer. 0.75. What is the ratio of the ATMs(per 100,000 adults) of Lesotho in 2006 to that in 2009?
Give a very brief answer. 0.59. What is the ratio of the ATMs(per 100,000 adults) of South Asia in 2006 to that in 2010?
Your answer should be compact. 0.26. What is the ratio of the ATMs(per 100,000 adults) of Fiji in 2006 to that in 2010?
Offer a very short reply. 0.64. What is the ratio of the ATMs(per 100,000 adults) of Italy in 2006 to that in 2010?
Make the answer very short. 0.8. What is the ratio of the ATMs(per 100,000 adults) of Lesotho in 2006 to that in 2010?
Give a very brief answer. 0.53. What is the ratio of the ATMs(per 100,000 adults) in South Asia in 2007 to that in 2008?
Offer a very short reply. 0.8. What is the ratio of the ATMs(per 100,000 adults) in Fiji in 2007 to that in 2008?
Your answer should be compact. 0.87. What is the ratio of the ATMs(per 100,000 adults) in Italy in 2007 to that in 2008?
Offer a terse response. 0.88. What is the ratio of the ATMs(per 100,000 adults) of Lesotho in 2007 to that in 2008?
Your answer should be compact. 0.86. What is the ratio of the ATMs(per 100,000 adults) in South Asia in 2007 to that in 2009?
Offer a very short reply. 0.69. What is the ratio of the ATMs(per 100,000 adults) of Fiji in 2007 to that in 2009?
Keep it short and to the point. 0.83. What is the ratio of the ATMs(per 100,000 adults) of Italy in 2007 to that in 2009?
Your answer should be compact. 0.82. What is the ratio of the ATMs(per 100,000 adults) in Lesotho in 2007 to that in 2009?
Offer a very short reply. 0.74. What is the ratio of the ATMs(per 100,000 adults) in South Asia in 2007 to that in 2010?
Make the answer very short. 0.63. What is the ratio of the ATMs(per 100,000 adults) of Fiji in 2007 to that in 2010?
Provide a short and direct response. 0.68. What is the ratio of the ATMs(per 100,000 adults) of Italy in 2007 to that in 2010?
Offer a very short reply. 0.87. What is the ratio of the ATMs(per 100,000 adults) of Lesotho in 2007 to that in 2010?
Provide a short and direct response. 0.67. What is the ratio of the ATMs(per 100,000 adults) of South Asia in 2008 to that in 2009?
Your answer should be very brief. 0.87. What is the ratio of the ATMs(per 100,000 adults) of Fiji in 2008 to that in 2009?
Provide a short and direct response. 0.95. What is the ratio of the ATMs(per 100,000 adults) in Italy in 2008 to that in 2009?
Keep it short and to the point. 0.93. What is the ratio of the ATMs(per 100,000 adults) in Lesotho in 2008 to that in 2009?
Offer a very short reply. 0.87. What is the ratio of the ATMs(per 100,000 adults) of South Asia in 2008 to that in 2010?
Your answer should be compact. 0.79. What is the ratio of the ATMs(per 100,000 adults) in Fiji in 2008 to that in 2010?
Make the answer very short. 0.78. What is the ratio of the ATMs(per 100,000 adults) in Lesotho in 2008 to that in 2010?
Make the answer very short. 0.79. What is the ratio of the ATMs(per 100,000 adults) of South Asia in 2009 to that in 2010?
Offer a terse response. 0.91. What is the ratio of the ATMs(per 100,000 adults) of Fiji in 2009 to that in 2010?
Offer a very short reply. 0.82. What is the ratio of the ATMs(per 100,000 adults) of Italy in 2009 to that in 2010?
Give a very brief answer. 1.07. What is the ratio of the ATMs(per 100,000 adults) of Lesotho in 2009 to that in 2010?
Give a very brief answer. 0.91. What is the difference between the highest and the second highest ATMs(per 100,000 adults) of South Asia?
Your answer should be compact. 0.39. What is the difference between the highest and the second highest ATMs(per 100,000 adults) of Fiji?
Provide a short and direct response. 5.92. What is the difference between the highest and the second highest ATMs(per 100,000 adults) in Italy?
Give a very brief answer. 6.91. What is the difference between the highest and the second highest ATMs(per 100,000 adults) of Lesotho?
Keep it short and to the point. 0.69. What is the difference between the highest and the lowest ATMs(per 100,000 adults) of South Asia?
Offer a very short reply. 4.16. What is the difference between the highest and the lowest ATMs(per 100,000 adults) in Fiji?
Your answer should be compact. 14.03. What is the difference between the highest and the lowest ATMs(per 100,000 adults) of Italy?
Your answer should be compact. 32.67. What is the difference between the highest and the lowest ATMs(per 100,000 adults) in Lesotho?
Give a very brief answer. 4.46. 